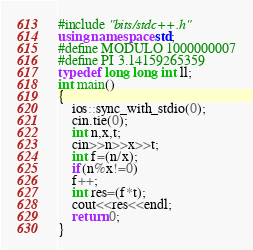<code> <loc_0><loc_0><loc_500><loc_500><_C++_>#include "bits/stdc++.h"
using namespace std;
#define MODULO 1000000007
#define PI 3.14159265359
typedef long long int ll;
int main()
{
    ios::sync_with_stdio(0);
    cin.tie(0);
    int n,x,t;
    cin>>n>>x>>t;
    int f=(n/x);
    if(n%x!=0)
    f++;
    int res=(f*t);
    cout<<res<<endl;
    return 0;
}
</code> 